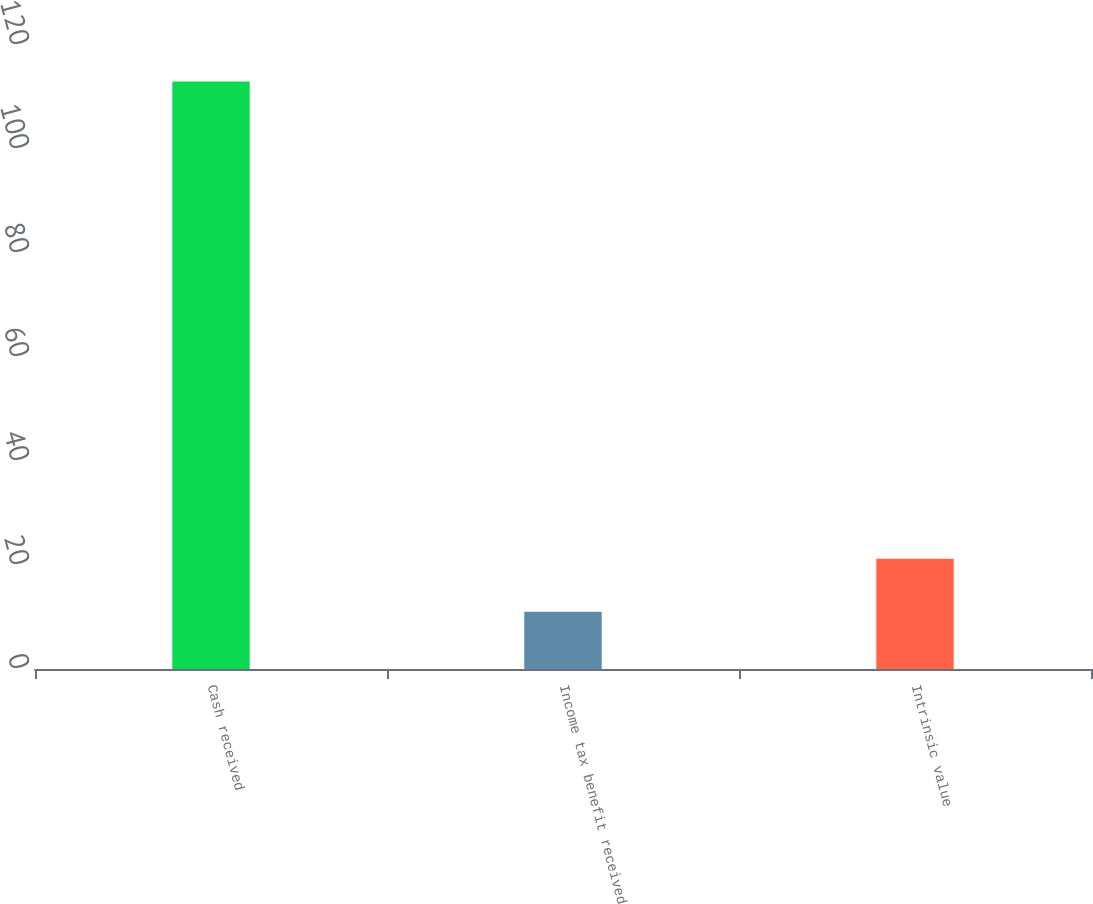Convert chart. <chart><loc_0><loc_0><loc_500><loc_500><bar_chart><fcel>Cash received<fcel>Income tax benefit received<fcel>Intrinsic value<nl><fcel>113<fcel>11<fcel>21.2<nl></chart> 